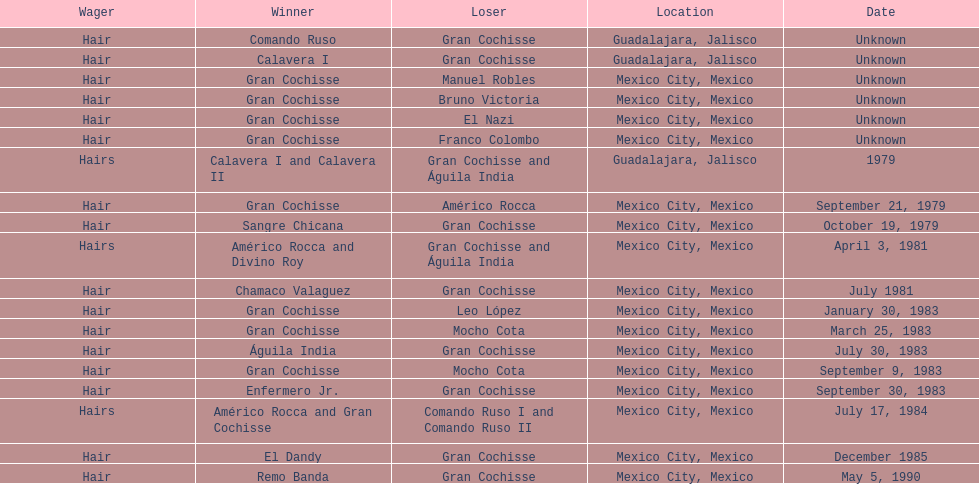When was gran chochisse first match that had a full date on record? September 21, 1979. 